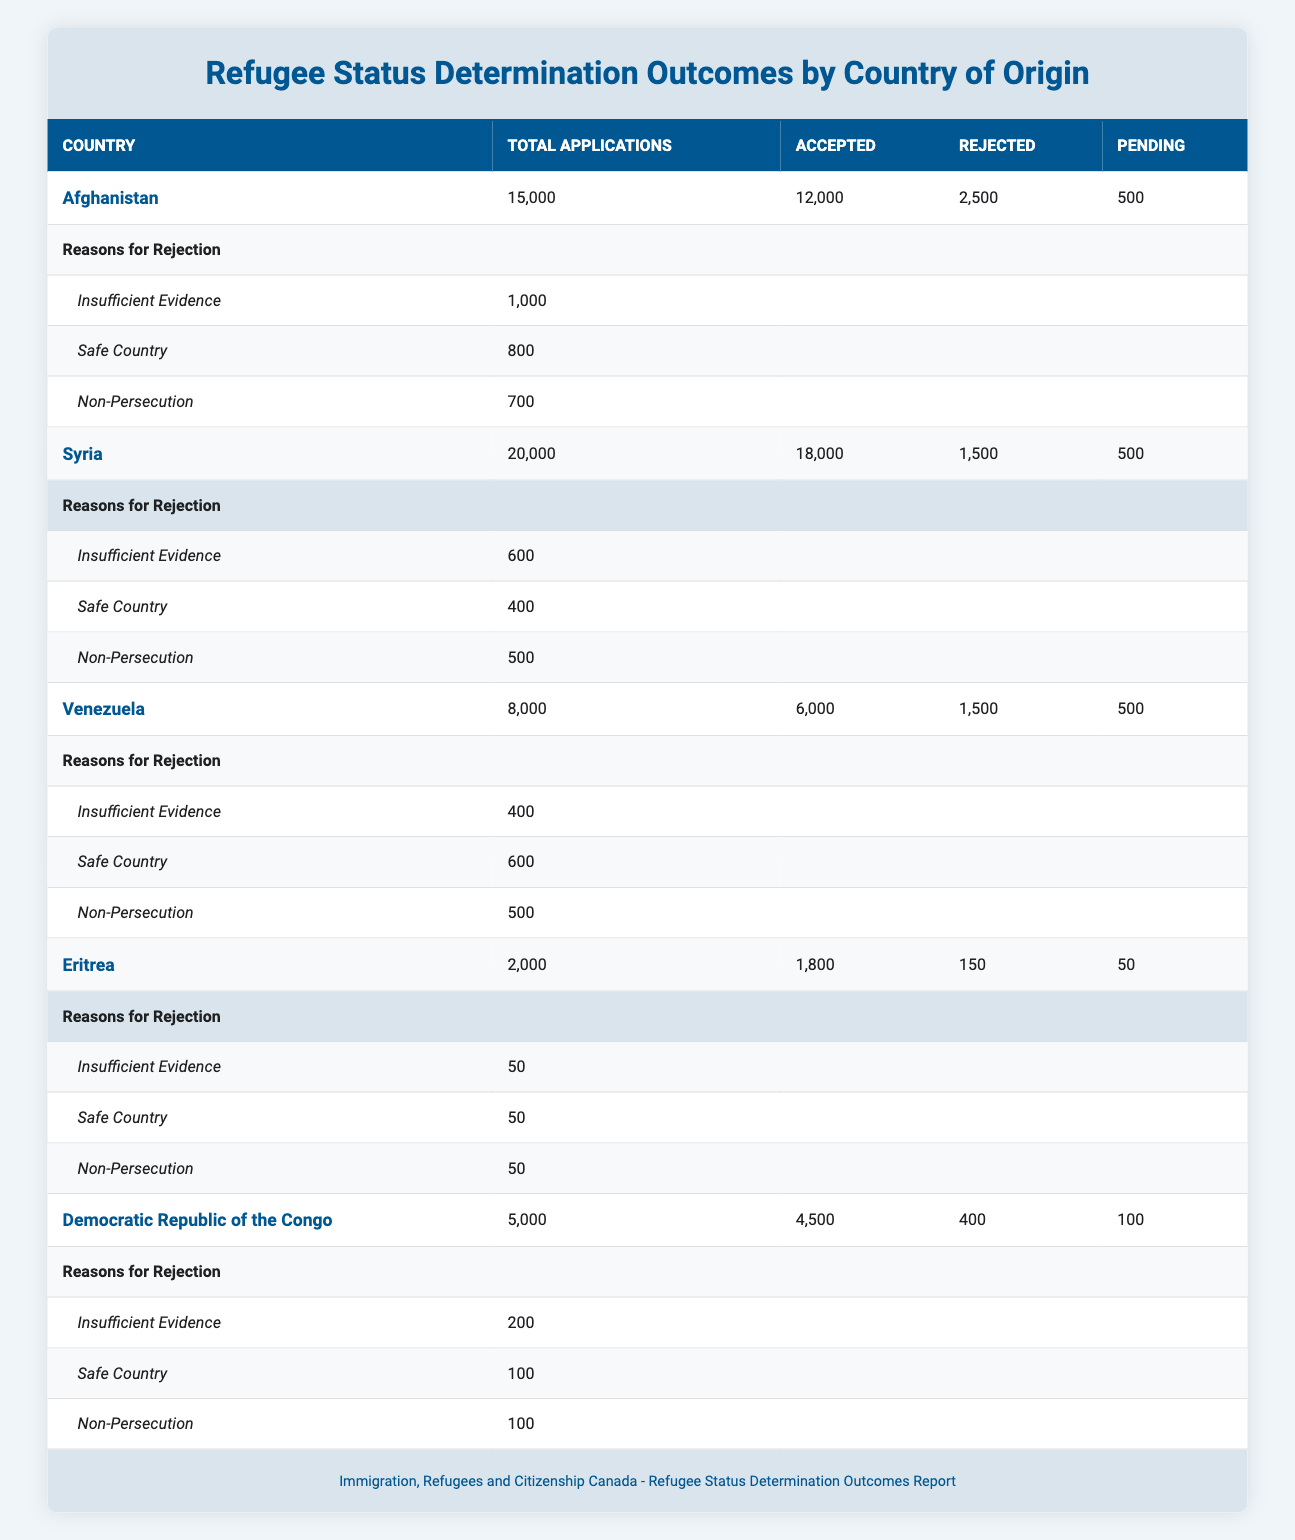What is the total number of refugee applications from Afghanistan? The total number of applications from Afghanistan is listed under "Total Applications" in the table. It is explicitly stated as 15,000.
Answer: 15,000 How many applications from Syria were rejected? The number of rejected applications from Syria is found in the "Rejected" column corresponding to Syria. It is given as 1,500.
Answer: 1,500 What is the total number of accepted applications across all countries listed? To find the total accepted applications, we add the accepted counts from each country: 12,000 (Afghanistan) + 18,000 (Syria) + 6,000 (Venezuela) + 1,800 (Eritrea) + 4,500 (Democratic Republic of the Congo) = 42,300.
Answer: 42,300 Which country has the highest percentage of accepted applications? To find the country with the highest percentage of accepted applications, we calculate the ratio for each country: Afghanistan (12,000/15,000) = 80%, Syria (18,000/20,000) = 90%, Venezuela (6,000/8,000) = 75%, Eritrea (1,800/2,000) = 90%, and Democratic Republic of the Congo (4,500/5,000) = 90%. The highest percentage is for Syria, Eritrea, and Democratic Republic of the Congo, each at 90%.
Answer: Syria, Eritrea, Democratic Republic of the Congo Is the number of pending applications for Venezuela greater than for Eritrea? The pending applications for Venezuela are 500, while for Eritrea, it is 50. We compare these two values and see that 500 is greater than 50.
Answer: Yes What is the total count of reasons for rejection from Afghanistan? To find the total reasons for rejection from Afghanistan, we add the reasons provided: Insufficient Evidence (1,000) + Safe Country (800) + Non-Persecution (700) = 2,500.
Answer: 2,500 How many applications from countries other than Eritrea were accepted? We sum the accepted applications from Afghanistan (12,000), Syria (18,000), Venezuela (6,000), and the Democratic Republic of the Congo (4,500): 12,000 + 18,000 + 6,000 + 4,500 = 40,500.
Answer: 40,500 What is the difference in accepted applications between Afghanistan and Syria? To find the difference, we subtract the accepted applications of Afghanistan (12,000) from that of Syria (18,000): 18,000 - 12,000 = 6,000.
Answer: 6,000 How many reasons for rejection were reported for the Democratic Republic of the Congo? The number of reasons for rejection for the Democratic Republic of the Congo is explicitly provided in the table. It shows there are three reasons cited: Insufficient Evidence, Safe Country, and Non-Persecution, making it a total of three reasons.
Answer: 3 